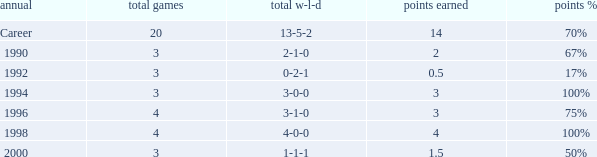Can you tell me the lowest Points won that has the Total matches of 4, and the Total W-L-H of 4-0-0? 4.0. 